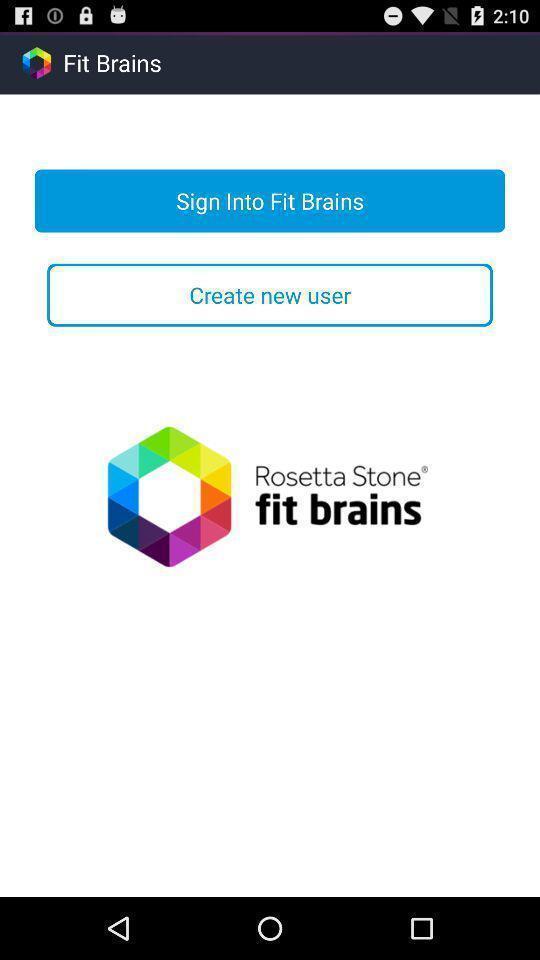Tell me about the visual elements in this screen capture. Welcome page for an application. 